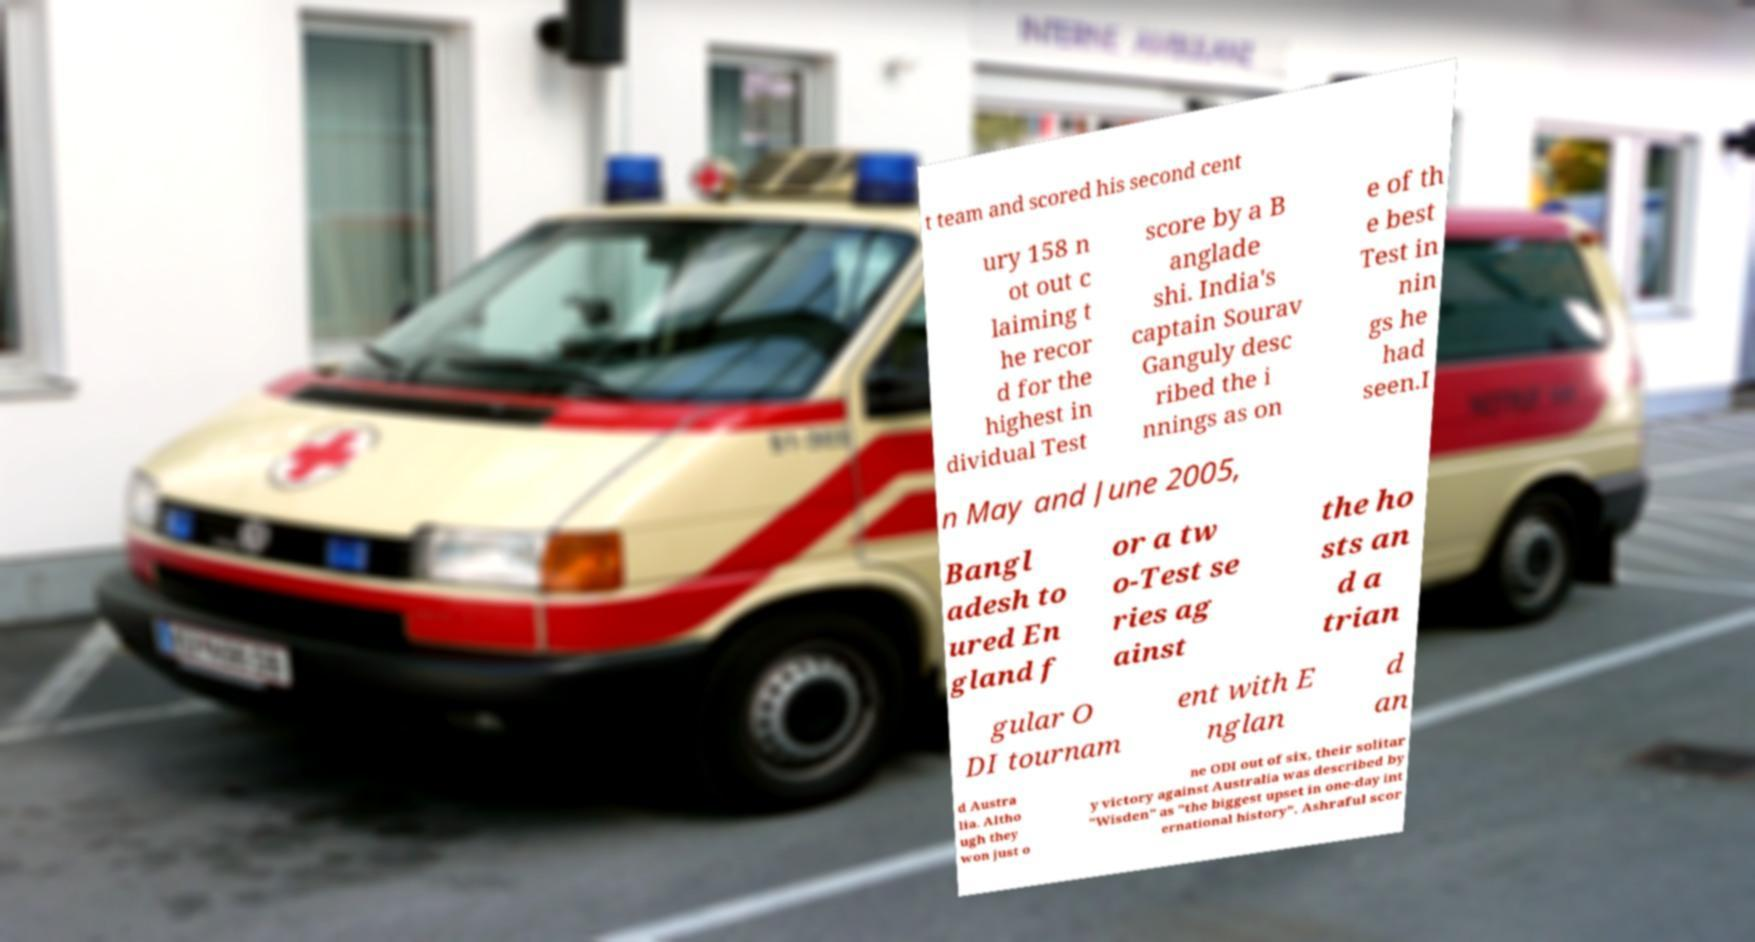Could you assist in decoding the text presented in this image and type it out clearly? t team and scored his second cent ury 158 n ot out c laiming t he recor d for the highest in dividual Test score by a B anglade shi. India's captain Sourav Ganguly desc ribed the i nnings as on e of th e best Test in nin gs he had seen.I n May and June 2005, Bangl adesh to ured En gland f or a tw o-Test se ries ag ainst the ho sts an d a trian gular O DI tournam ent with E nglan d an d Austra lia. Altho ugh they won just o ne ODI out of six, their solitar y victory against Australia was described by "Wisden" as "the biggest upset in one-day int ernational history". Ashraful scor 